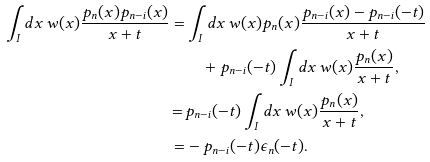Convert formula to latex. <formula><loc_0><loc_0><loc_500><loc_500>\int _ { I } d x \, w ( x ) \frac { p _ { n } ( x ) p _ { n - i } ( x ) } { x + t } = & \int _ { I } d x \, w ( x ) p _ { n } ( x ) \frac { p _ { n - i } ( x ) - p _ { n - i } ( - t ) } { x + t } \\ & \quad + p _ { n - i } ( - t ) \int _ { I } d x \, w ( x ) \frac { p _ { n } ( x ) } { x + t } , \\ = \, & p _ { n - i } ( - t ) \int _ { I } d x \, w ( x ) \frac { p _ { n } ( x ) } { x + t } , \\ = & - p _ { n - i } ( - t ) \epsilon _ { n } ( - t ) .</formula> 